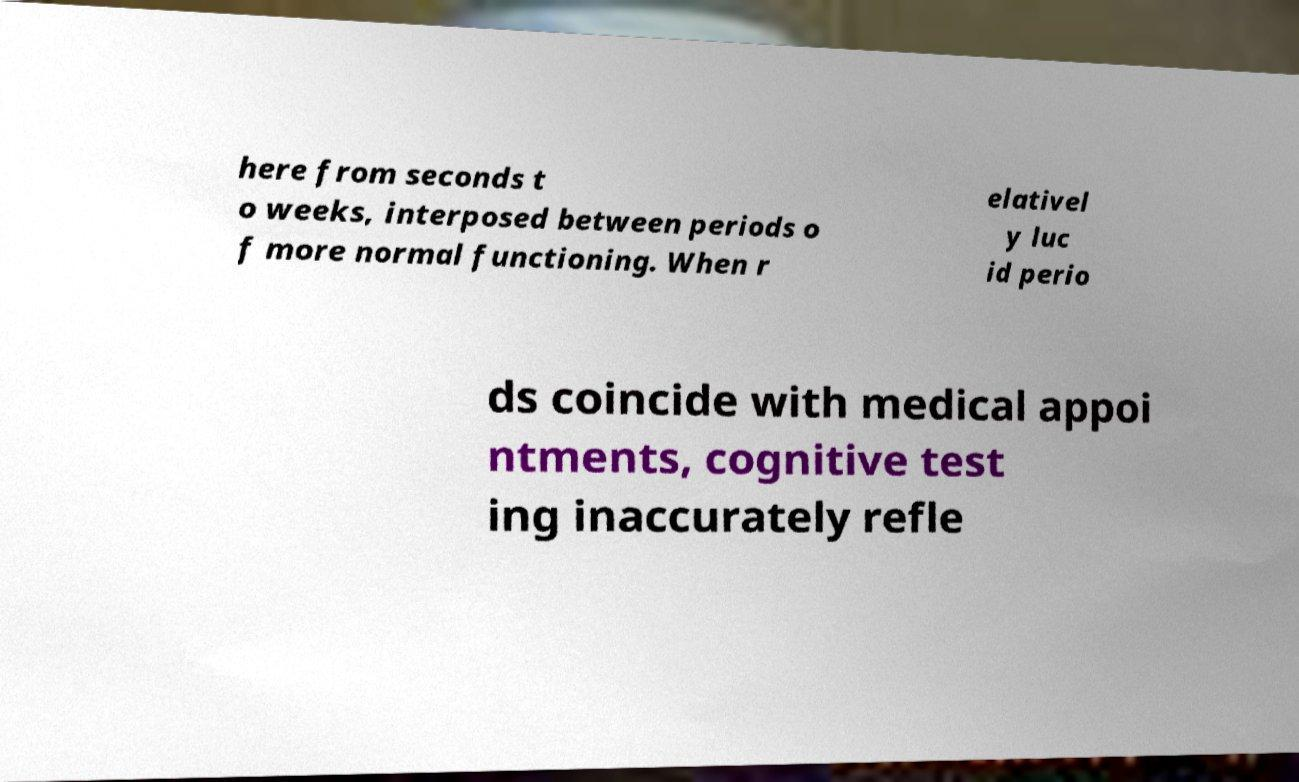Please identify and transcribe the text found in this image. here from seconds t o weeks, interposed between periods o f more normal functioning. When r elativel y luc id perio ds coincide with medical appoi ntments, cognitive test ing inaccurately refle 